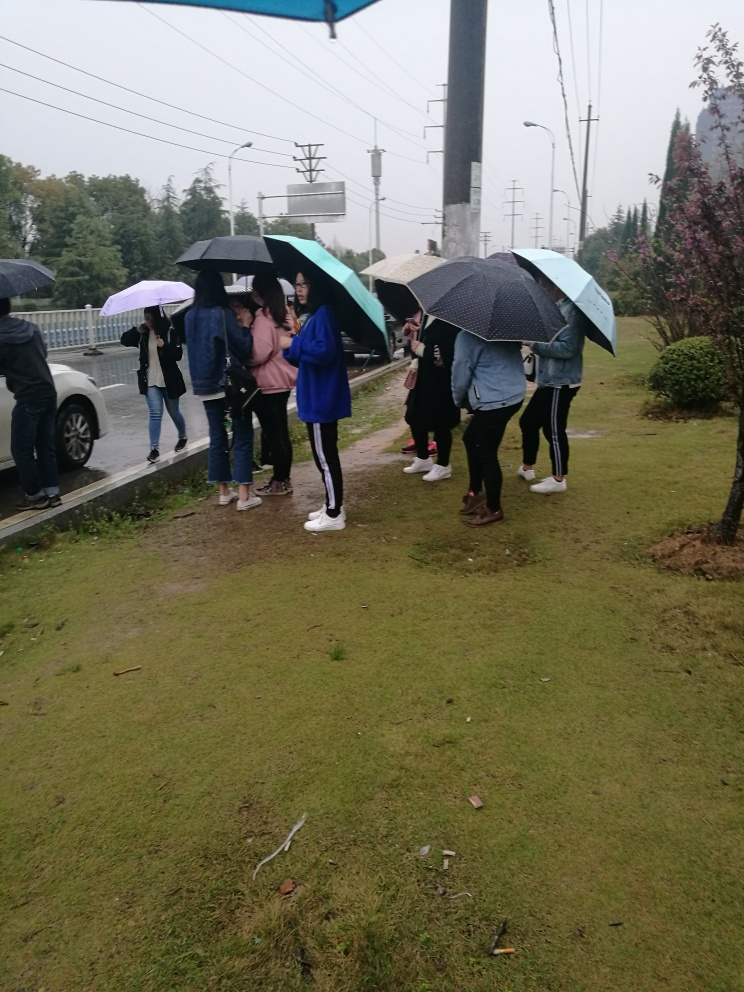Is the overall clarity of the image average? The image is reasonably clear, capturing details such as individual people, the texture of the grass, and the varied umbrellas under an overcast sky, although it's not remarkably sharp or detailed. 